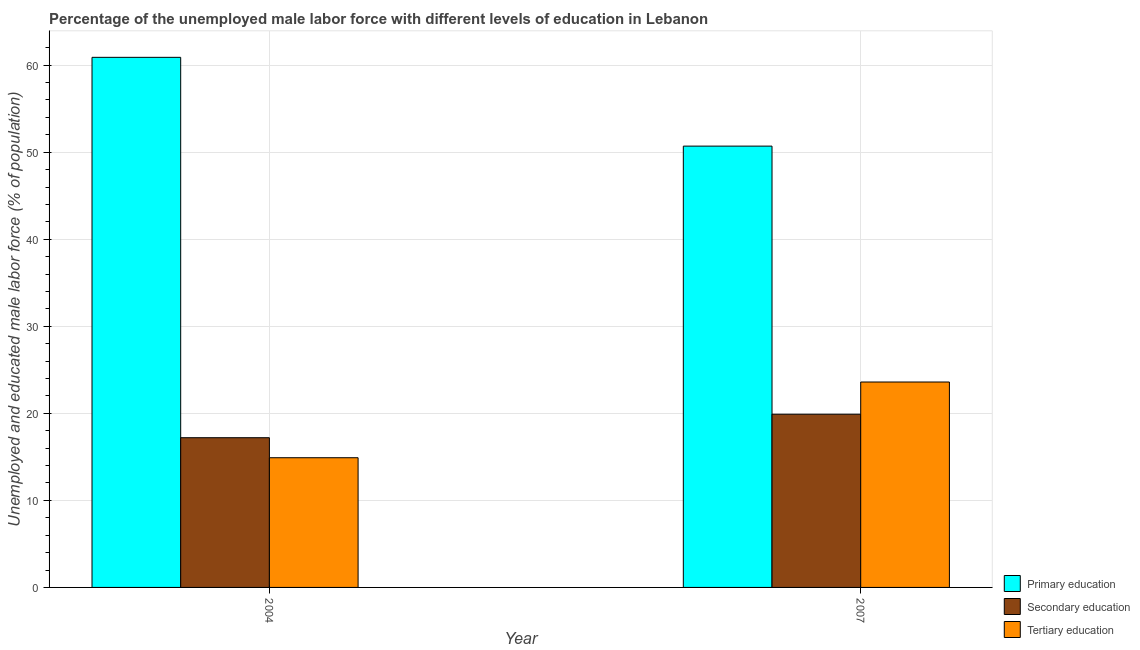How many groups of bars are there?
Your answer should be compact. 2. Are the number of bars per tick equal to the number of legend labels?
Offer a very short reply. Yes. Are the number of bars on each tick of the X-axis equal?
Offer a terse response. Yes. How many bars are there on the 2nd tick from the left?
Your answer should be compact. 3. How many bars are there on the 2nd tick from the right?
Your answer should be compact. 3. In how many cases, is the number of bars for a given year not equal to the number of legend labels?
Offer a terse response. 0. What is the percentage of male labor force who received tertiary education in 2004?
Make the answer very short. 14.9. Across all years, what is the maximum percentage of male labor force who received primary education?
Make the answer very short. 60.9. Across all years, what is the minimum percentage of male labor force who received secondary education?
Your answer should be compact. 17.2. In which year was the percentage of male labor force who received tertiary education maximum?
Provide a succinct answer. 2007. What is the total percentage of male labor force who received tertiary education in the graph?
Ensure brevity in your answer.  38.5. What is the difference between the percentage of male labor force who received primary education in 2004 and that in 2007?
Provide a short and direct response. 10.2. What is the difference between the percentage of male labor force who received tertiary education in 2007 and the percentage of male labor force who received primary education in 2004?
Ensure brevity in your answer.  8.7. What is the average percentage of male labor force who received secondary education per year?
Provide a short and direct response. 18.55. In the year 2007, what is the difference between the percentage of male labor force who received secondary education and percentage of male labor force who received tertiary education?
Ensure brevity in your answer.  0. In how many years, is the percentage of male labor force who received tertiary education greater than 48 %?
Your answer should be compact. 0. What is the ratio of the percentage of male labor force who received secondary education in 2004 to that in 2007?
Provide a succinct answer. 0.86. Is the percentage of male labor force who received primary education in 2004 less than that in 2007?
Provide a succinct answer. No. What does the 2nd bar from the left in 2007 represents?
Give a very brief answer. Secondary education. What does the 1st bar from the right in 2007 represents?
Your answer should be compact. Tertiary education. Is it the case that in every year, the sum of the percentage of male labor force who received primary education and percentage of male labor force who received secondary education is greater than the percentage of male labor force who received tertiary education?
Give a very brief answer. Yes. What is the difference between two consecutive major ticks on the Y-axis?
Keep it short and to the point. 10. Does the graph contain grids?
Give a very brief answer. Yes. How are the legend labels stacked?
Offer a terse response. Vertical. What is the title of the graph?
Your response must be concise. Percentage of the unemployed male labor force with different levels of education in Lebanon. What is the label or title of the X-axis?
Ensure brevity in your answer.  Year. What is the label or title of the Y-axis?
Keep it short and to the point. Unemployed and educated male labor force (% of population). What is the Unemployed and educated male labor force (% of population) in Primary education in 2004?
Provide a succinct answer. 60.9. What is the Unemployed and educated male labor force (% of population) of Secondary education in 2004?
Your response must be concise. 17.2. What is the Unemployed and educated male labor force (% of population) in Tertiary education in 2004?
Provide a short and direct response. 14.9. What is the Unemployed and educated male labor force (% of population) of Primary education in 2007?
Keep it short and to the point. 50.7. What is the Unemployed and educated male labor force (% of population) in Secondary education in 2007?
Your answer should be compact. 19.9. What is the Unemployed and educated male labor force (% of population) in Tertiary education in 2007?
Your answer should be compact. 23.6. Across all years, what is the maximum Unemployed and educated male labor force (% of population) in Primary education?
Offer a terse response. 60.9. Across all years, what is the maximum Unemployed and educated male labor force (% of population) of Secondary education?
Provide a short and direct response. 19.9. Across all years, what is the maximum Unemployed and educated male labor force (% of population) of Tertiary education?
Give a very brief answer. 23.6. Across all years, what is the minimum Unemployed and educated male labor force (% of population) of Primary education?
Offer a very short reply. 50.7. Across all years, what is the minimum Unemployed and educated male labor force (% of population) in Secondary education?
Ensure brevity in your answer.  17.2. Across all years, what is the minimum Unemployed and educated male labor force (% of population) in Tertiary education?
Your response must be concise. 14.9. What is the total Unemployed and educated male labor force (% of population) of Primary education in the graph?
Provide a succinct answer. 111.6. What is the total Unemployed and educated male labor force (% of population) in Secondary education in the graph?
Your response must be concise. 37.1. What is the total Unemployed and educated male labor force (% of population) of Tertiary education in the graph?
Your answer should be compact. 38.5. What is the difference between the Unemployed and educated male labor force (% of population) in Primary education in 2004 and that in 2007?
Your answer should be compact. 10.2. What is the difference between the Unemployed and educated male labor force (% of population) in Primary education in 2004 and the Unemployed and educated male labor force (% of population) in Secondary education in 2007?
Make the answer very short. 41. What is the difference between the Unemployed and educated male labor force (% of population) in Primary education in 2004 and the Unemployed and educated male labor force (% of population) in Tertiary education in 2007?
Your answer should be compact. 37.3. What is the difference between the Unemployed and educated male labor force (% of population) of Secondary education in 2004 and the Unemployed and educated male labor force (% of population) of Tertiary education in 2007?
Offer a very short reply. -6.4. What is the average Unemployed and educated male labor force (% of population) of Primary education per year?
Provide a succinct answer. 55.8. What is the average Unemployed and educated male labor force (% of population) of Secondary education per year?
Your answer should be compact. 18.55. What is the average Unemployed and educated male labor force (% of population) in Tertiary education per year?
Your answer should be compact. 19.25. In the year 2004, what is the difference between the Unemployed and educated male labor force (% of population) of Primary education and Unemployed and educated male labor force (% of population) of Secondary education?
Give a very brief answer. 43.7. In the year 2007, what is the difference between the Unemployed and educated male labor force (% of population) in Primary education and Unemployed and educated male labor force (% of population) in Secondary education?
Provide a short and direct response. 30.8. In the year 2007, what is the difference between the Unemployed and educated male labor force (% of population) in Primary education and Unemployed and educated male labor force (% of population) in Tertiary education?
Keep it short and to the point. 27.1. What is the ratio of the Unemployed and educated male labor force (% of population) in Primary education in 2004 to that in 2007?
Offer a very short reply. 1.2. What is the ratio of the Unemployed and educated male labor force (% of population) in Secondary education in 2004 to that in 2007?
Ensure brevity in your answer.  0.86. What is the ratio of the Unemployed and educated male labor force (% of population) of Tertiary education in 2004 to that in 2007?
Offer a terse response. 0.63. What is the difference between the highest and the second highest Unemployed and educated male labor force (% of population) in Primary education?
Provide a short and direct response. 10.2. What is the difference between the highest and the second highest Unemployed and educated male labor force (% of population) of Secondary education?
Provide a succinct answer. 2.7. What is the difference between the highest and the lowest Unemployed and educated male labor force (% of population) in Primary education?
Give a very brief answer. 10.2. 